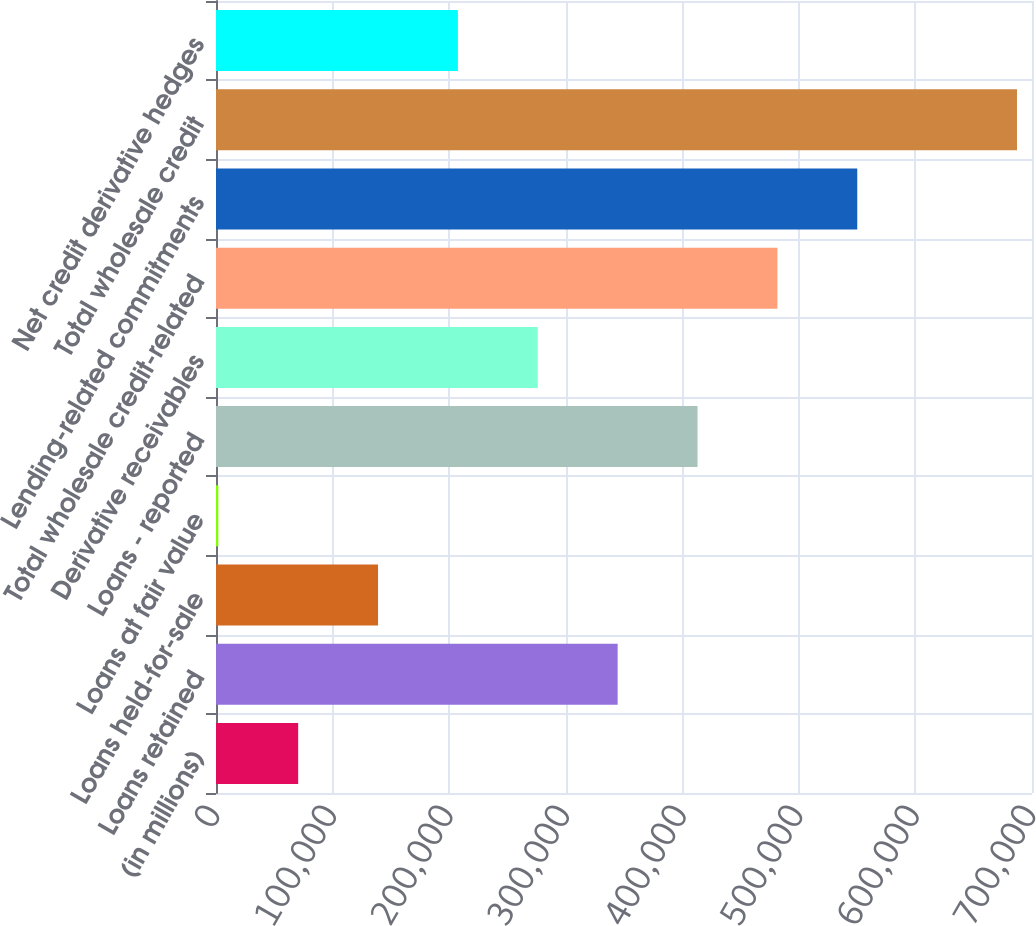Convert chart to OTSL. <chart><loc_0><loc_0><loc_500><loc_500><bar_chart><fcel>(in millions)<fcel>Loans retained<fcel>Loans held-for-sale<fcel>Loans at fair value<fcel>Loans - reported<fcel>Derivative receivables<fcel>Total wholesale credit-related<fcel>Lending-related commitments<fcel>Total wholesale credit<fcel>Net credit derivative hedges<nl><fcel>70490.9<fcel>344550<fcel>139006<fcel>1976<fcel>413065<fcel>276036<fcel>481580<fcel>550095<fcel>687125<fcel>207521<nl></chart> 